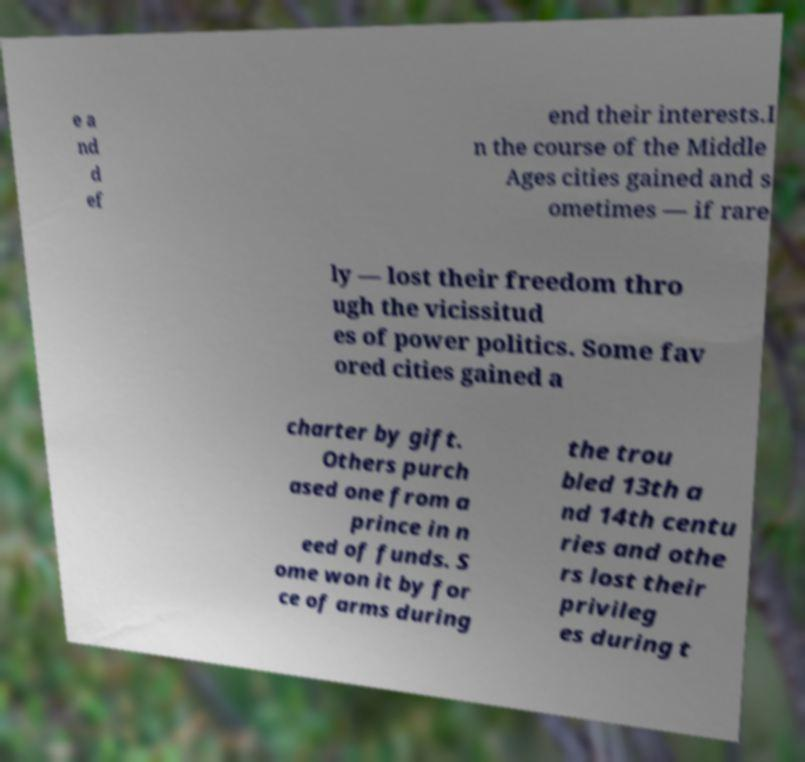For documentation purposes, I need the text within this image transcribed. Could you provide that? e a nd d ef end their interests.I n the course of the Middle Ages cities gained and s ometimes — if rare ly — lost their freedom thro ugh the vicissitud es of power politics. Some fav ored cities gained a charter by gift. Others purch ased one from a prince in n eed of funds. S ome won it by for ce of arms during the trou bled 13th a nd 14th centu ries and othe rs lost their privileg es during t 